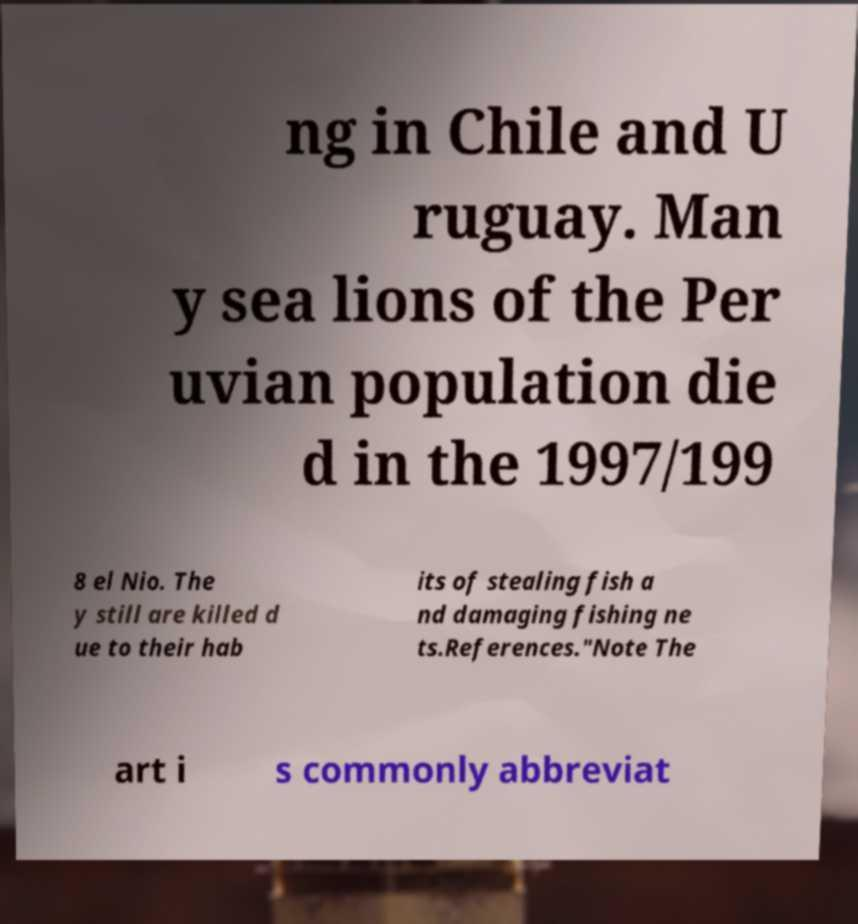Please read and relay the text visible in this image. What does it say? ng in Chile and U ruguay. Man y sea lions of the Per uvian population die d in the 1997/199 8 el Nio. The y still are killed d ue to their hab its of stealing fish a nd damaging fishing ne ts.References."Note The art i s commonly abbreviat 